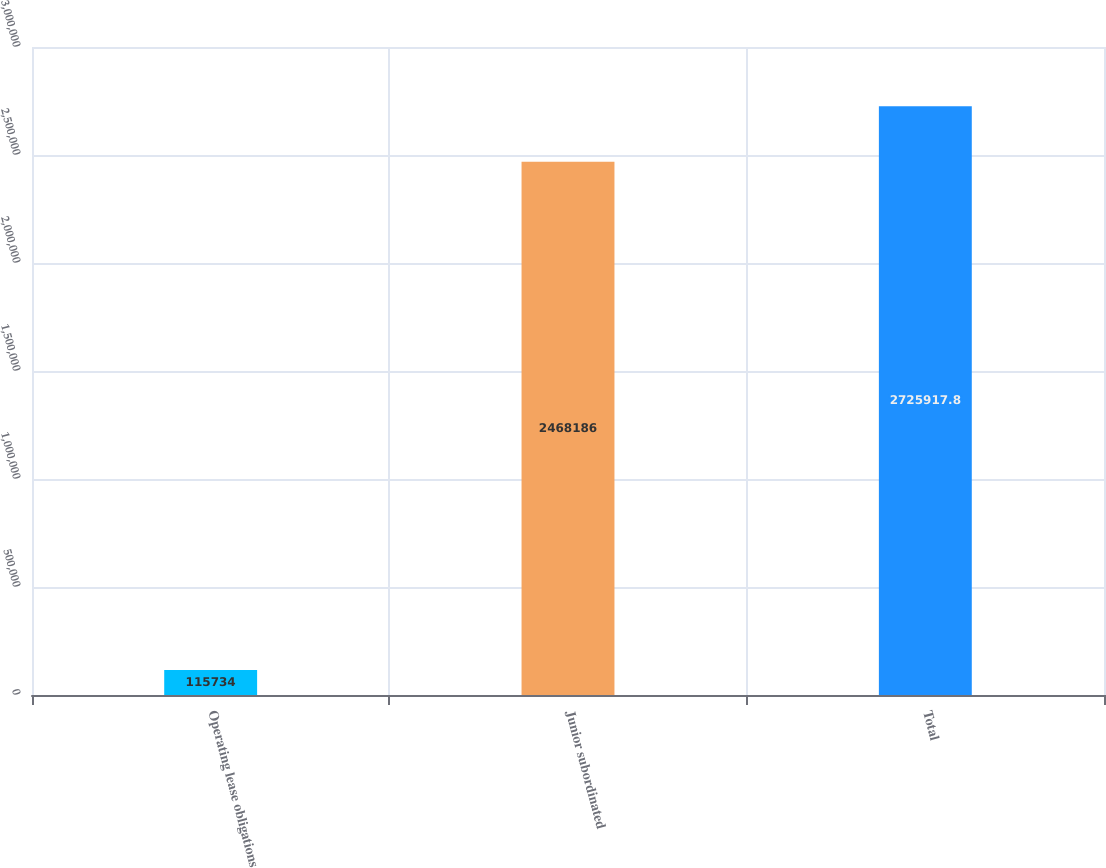Convert chart to OTSL. <chart><loc_0><loc_0><loc_500><loc_500><bar_chart><fcel>Operating lease obligations<fcel>Junior subordinated<fcel>Total<nl><fcel>115734<fcel>2.46819e+06<fcel>2.72592e+06<nl></chart> 